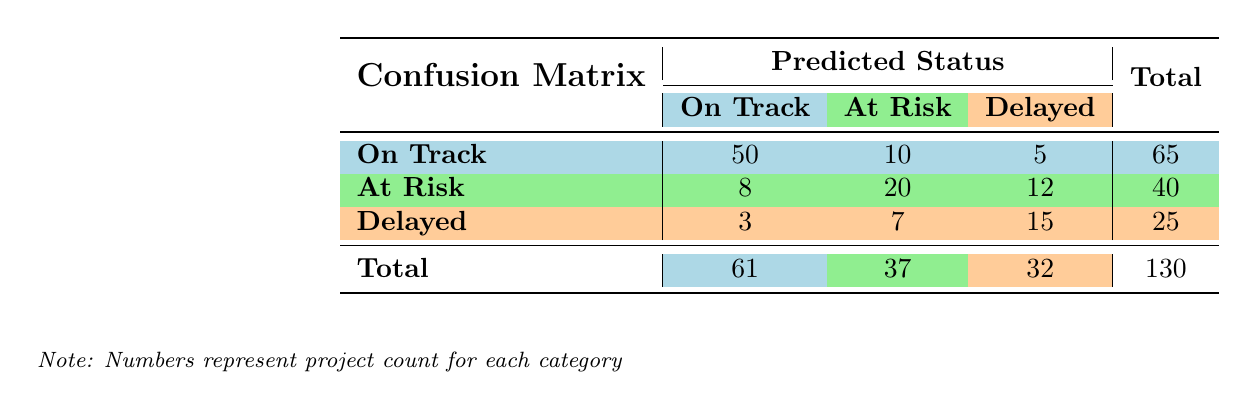What is the total count for projects that are predicted to be "On Track"? To find the total count for projects predicted to be "On Track," we look at the last row in the "On Track" column. The values are 50 (true positive) + 8 (false negative) + 3 (false positive), so the total is 50 + 8 + 3 = 61.
Answer: 61 What is the number of projects that are actually "At Risk" but predicted as "Delayed"? In the table, we check the row where the actual status is "At Risk" and find the count for the "Delayed" prediction, which is 12.
Answer: 12 How many projects are correctly classified as "Delayed"? This refers to the count in the "Delayed" category where both actual and predicted statuses match, which is found in the last row of the "Delayed" column. The count is 15.
Answer: 15 Is there a greater number of projects classified as "At Risk" than those classified as "Delayed"? We compare the total counts for "At Risk" (40) and "Delayed" (25). The number of "At Risk" projects is indeed greater than "Delayed," making the statement true.
Answer: Yes What percentage of projects predicted to be "At Risk" are actually "At Risk"? To find this percentage, we take the count of true positives (20) and divide it by the total predicted "At Risk" (37) and then multiply by 100: (20 / 37) * 100 ≈ 54.05%.
Answer: 54.05% How many projects were predicted incorrectly as "Delayed"? We sum the counts of projects that are not actually "Delayed" but were predicted as "Delayed." This includes 5 projects that were actually "On Track" and 12 projects that were "At Risk," totaling 17.
Answer: 17 What is the total number of projects that are at risk of delays? To find this, we look for the total of both "At Risk" and "Delayed" statuses. This gives: (40 from "At Risk" row) + (25 from "Delayed" row) = 65.
Answer: 65 What is the least predicted status for projects that are actually "On Track"? The least predicted status in the "On Track" row is "Delayed," with a count of 5 projects.
Answer: 5 How many projects are either "On Track" or "Delayed"? We take the total counts for "On Track" (65) and "Delayed" (25) and sum them. The total is 65 + 25 = 90.
Answer: 90 